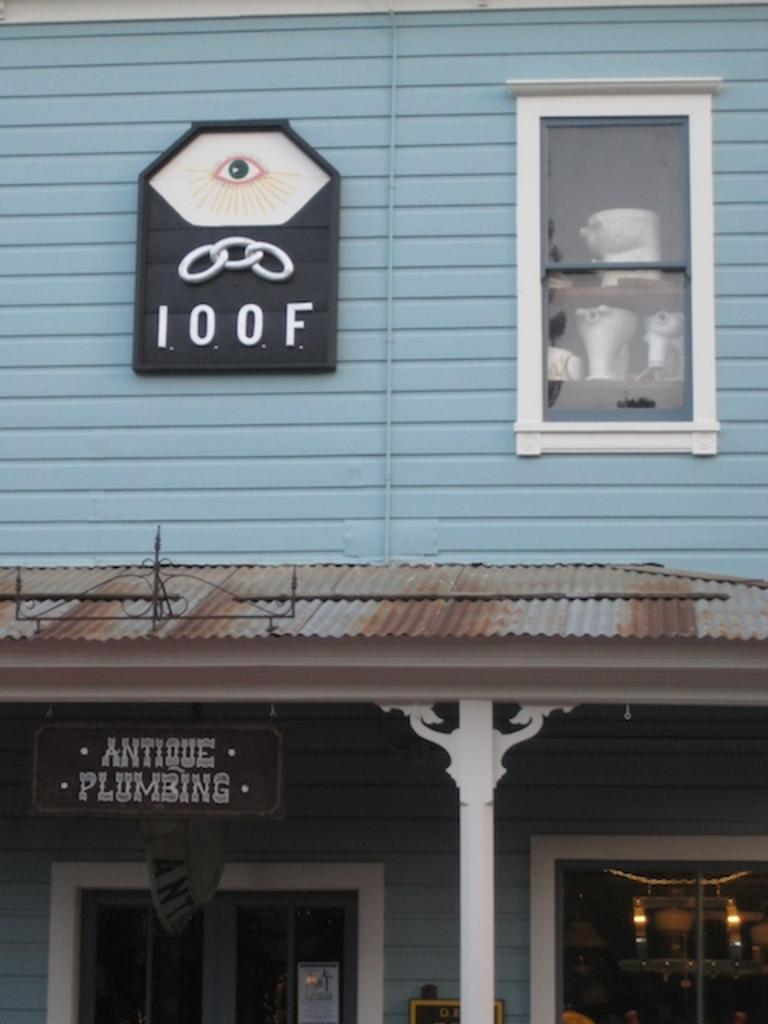Provide a one-sentence caption for the provided image. A building that says IOOF and Antique Plumbing on it. 